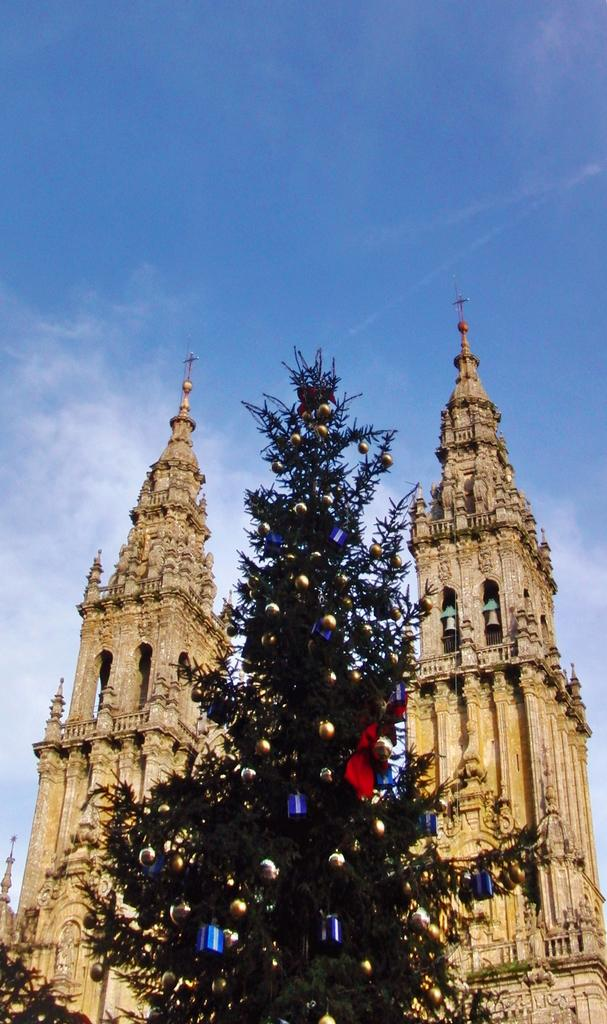What is the main subject of the image? There is a Christmas tree in the image. What can be seen in the background of the image? There are churches and the sky visible in the background of the image. Can you tell me how many horses are standing next to the Christmas tree in the image? There are no horses present in the image; it features a Christmas tree and churches in the background. Is there a woman covering the Christmas tree with a blanket in the image? There is no woman or blanket covering the Christmas tree in the image. 